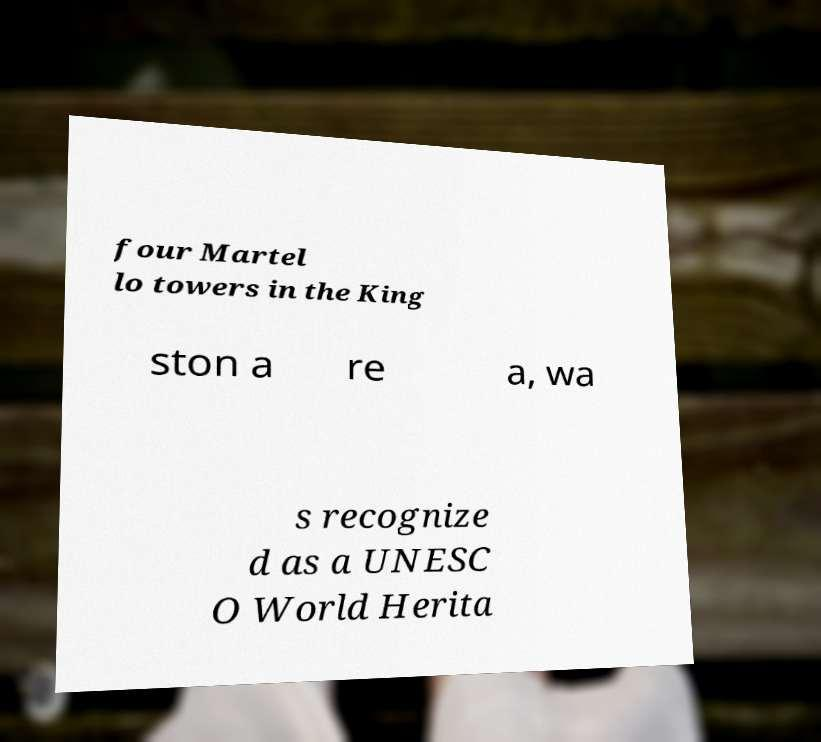Can you accurately transcribe the text from the provided image for me? four Martel lo towers in the King ston a re a, wa s recognize d as a UNESC O World Herita 